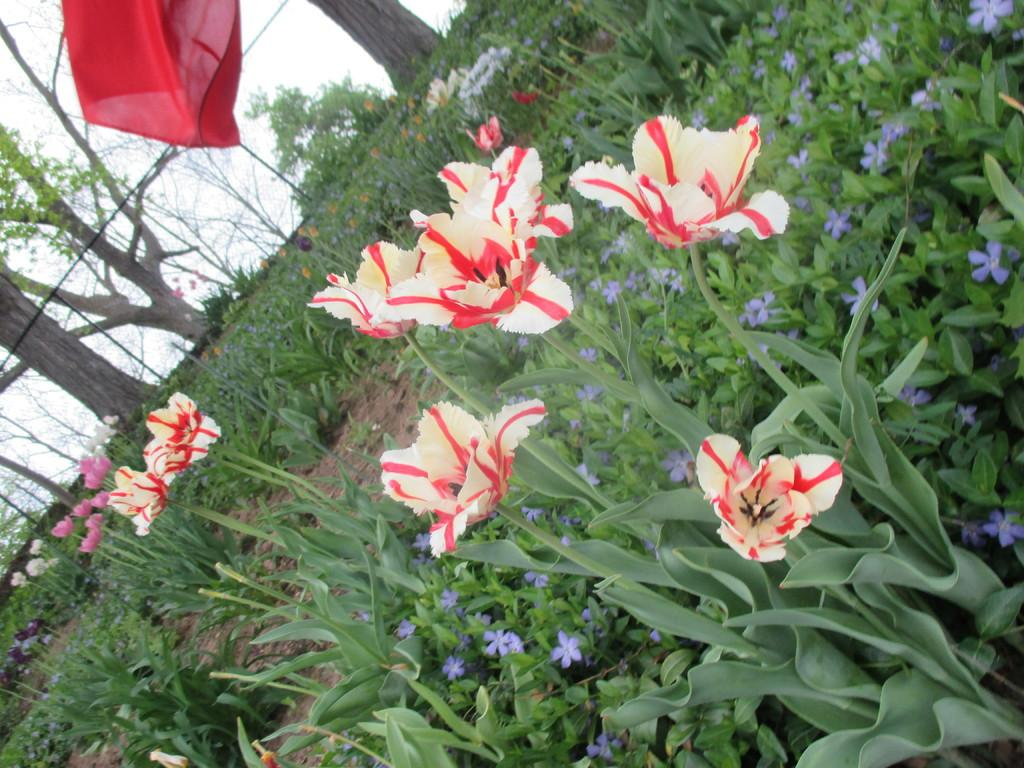What type of flora can be seen in the image? There are flowers and plants in the image. What can be seen in the background of the image? There are trees in the background of the image. What is visible at the top of the image? The sky is visible at the top of the image. What type of toy can be seen in the image? There is no toy present in the image. Can you fold the trees in the background of the image? The trees in the background cannot be folded, as they are part of the image and not physical objects. 